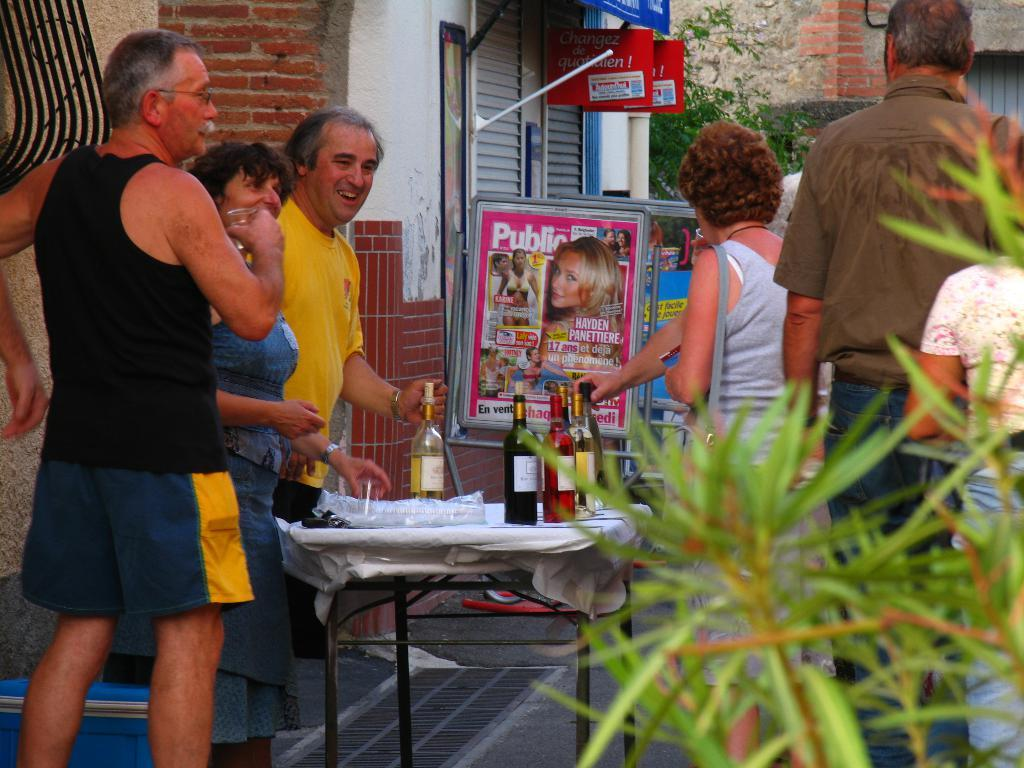Provide a one-sentence caption for the provided image. a group of people outside with a Public magazine near them. 